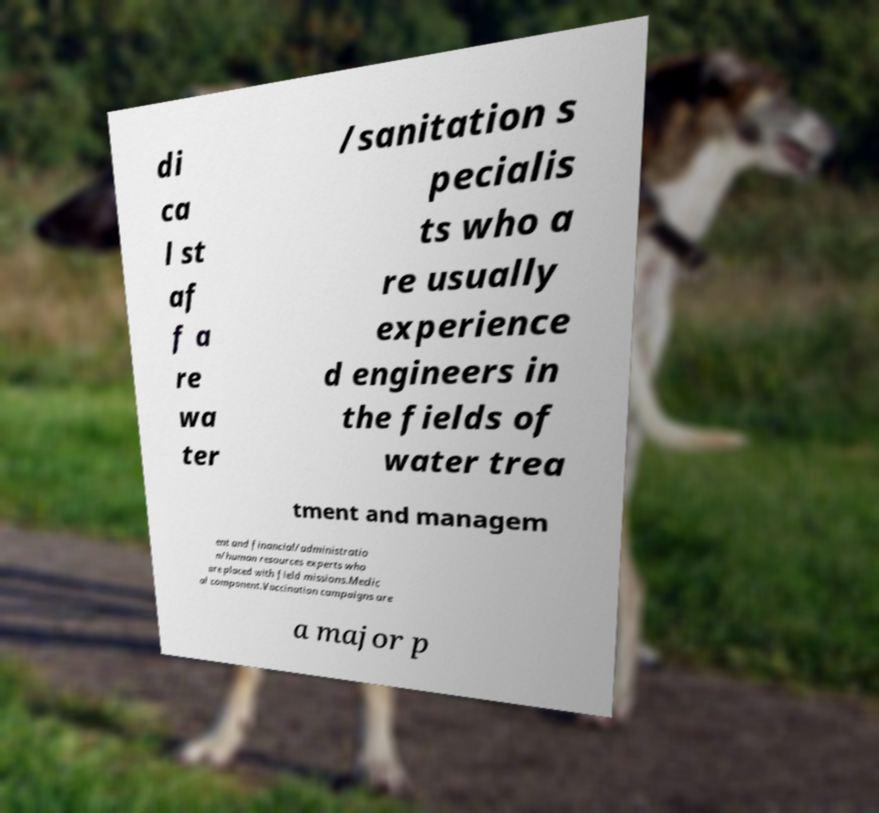What messages or text are displayed in this image? I need them in a readable, typed format. di ca l st af f a re wa ter /sanitation s pecialis ts who a re usually experience d engineers in the fields of water trea tment and managem ent and financial/administratio n/human resources experts who are placed with field missions.Medic al component.Vaccination campaigns are a major p 